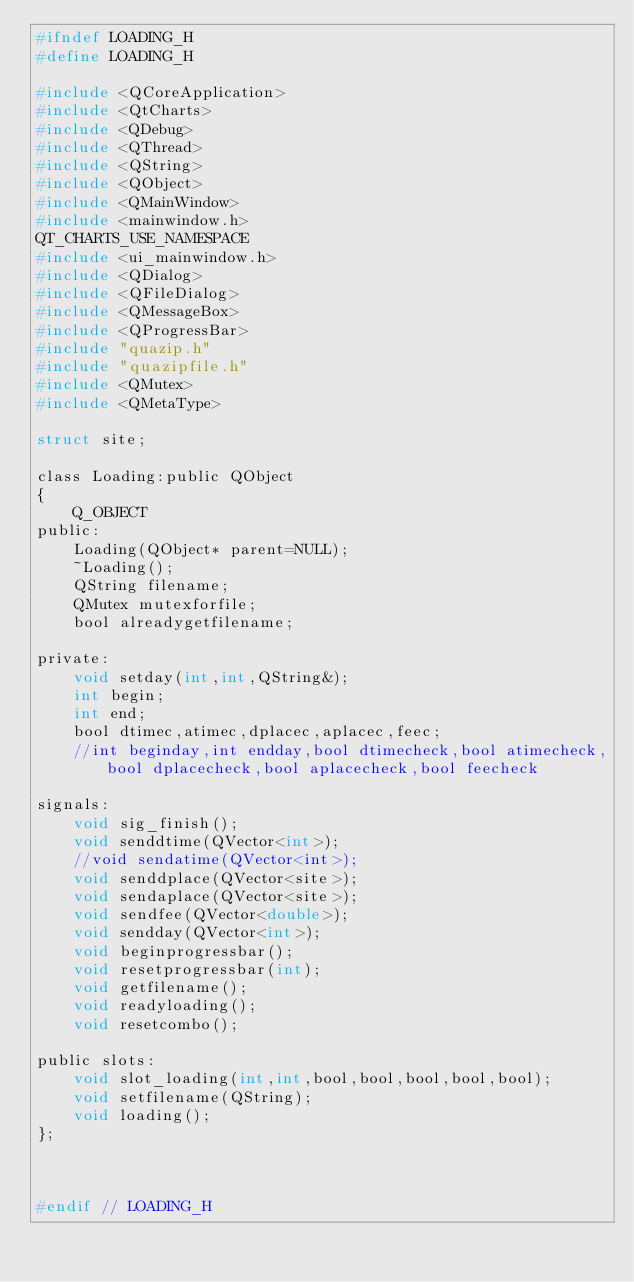Convert code to text. <code><loc_0><loc_0><loc_500><loc_500><_C_>#ifndef LOADING_H
#define LOADING_H

#include <QCoreApplication>
#include <QtCharts>
#include <QDebug>
#include <QThread>
#include <QString>
#include <QObject>
#include <QMainWindow>
#include <mainwindow.h>
QT_CHARTS_USE_NAMESPACE
#include <ui_mainwindow.h>
#include <QDialog>
#include <QFileDialog>
#include <QMessageBox>
#include <QProgressBar>
#include "quazip.h"
#include "quazipfile.h"
#include <QMutex>
#include <QMetaType>

struct site;

class Loading:public QObject
{
    Q_OBJECT
public:
    Loading(QObject* parent=NULL);
    ~Loading();
    QString filename;
    QMutex mutexforfile;
    bool alreadygetfilename;

private:
    void setday(int,int,QString&);
    int begin;
    int end;
    bool dtimec,atimec,dplacec,aplacec,feec;
    //int beginday,int endday,bool dtimecheck,bool atimecheck,bool dplacecheck,bool aplacecheck,bool feecheck

signals:
    void sig_finish();
    void senddtime(QVector<int>);
    //void sendatime(QVector<int>);
    void senddplace(QVector<site>);
    void sendaplace(QVector<site>);
    void sendfee(QVector<double>);
    void sendday(QVector<int>);
    void beginprogressbar();
    void resetprogressbar(int);
    void getfilename();
    void readyloading();
    void resetcombo();

public slots:
    void slot_loading(int,int,bool,bool,bool,bool,bool);
    void setfilename(QString);
    void loading();
};



#endif // LOADING_H
</code> 